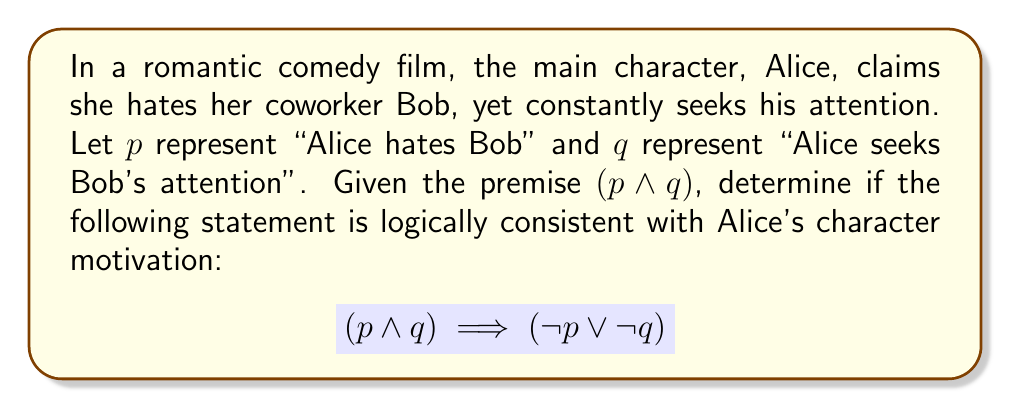Could you help me with this problem? To determine the logical consistency of Alice's character motivation, we need to analyze the given implication using truth tables and logical laws.

1. First, let's create a truth table for the premise $(p \land q)$:

   | $p$ | $q$ | $p \land q$ |
   |-----|-----|-------------|
   | T   | T   | T           |
   | T   | F   | F           |
   | F   | T   | F           |
   | F   | F   | F           |

2. Now, let's evaluate the right side of the implication $(\neg p \lor \neg q)$:

   | $p$ | $q$ | $\neg p$ | $\neg q$ | $\neg p \lor \neg q$ |
   |-----|-----|----------|----------|----------------------|
   | T   | T   | F        | F        | F                    |
   | T   | F   | F        | T        | T                    |
   | F   | T   | T        | F        | T                    |
   | F   | F   | T        | T        | T                    |

3. Combining the results, we get the truth table for the entire implication:

   | $p$ | $q$ | $p \land q$ | $\neg p \lor \neg q$ | $(p \land q) \implies (\neg p \lor \neg q)$ |
   |-----|-----|-------------|----------------------|---------------------------------------------|
   | T   | T   | T           | F                    | F                                           |
   | T   | F   | F           | T                    | T                                           |
   | F   | T   | F           | T                    | T                                           |
   | F   | F   | F           | T                    | T                                           |

4. For an implication to be true, it must be true for all possible input combinations. In this case, we see that when both $p$ and $q$ are true (first row), the implication is false.

5. This result indicates that the given statement is not logically consistent with Alice's character motivation. If Alice truly hates Bob $(p)$ and seeks his attention $(q)$, it cannot logically imply that she either doesn't hate him $(\neg p)$ or doesn't seek his attention $(\neg q)$.

From a film reviewer's perspective, this logical inconsistency highlights the unrealistic expectations often perpetuated in romantic comedies. It shows how characters' actions and stated feelings are often at odds, creating a narrative that doesn't align with realistic relationship dynamics.
Answer: The statement $(p \land q) \implies (\neg p \lor \neg q)$ is not logically consistent with Alice's character motivation. 